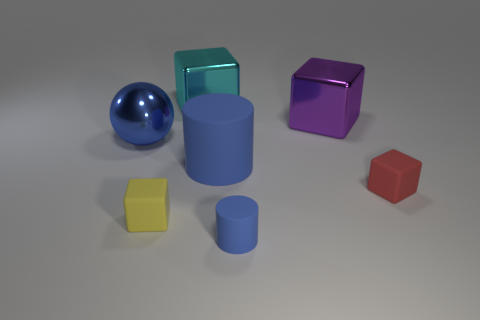Subtract all yellow matte cubes. How many cubes are left? 3 Subtract all red cubes. How many cubes are left? 3 Subtract all cylinders. How many objects are left? 5 Subtract 2 blocks. How many blocks are left? 2 Add 4 tiny red blocks. How many tiny red blocks exist? 5 Add 3 tiny rubber blocks. How many objects exist? 10 Subtract 0 gray cylinders. How many objects are left? 7 Subtract all yellow balls. Subtract all brown cylinders. How many balls are left? 1 Subtract all green cylinders. How many red cubes are left? 1 Subtract all blue cylinders. Subtract all big metallic spheres. How many objects are left? 4 